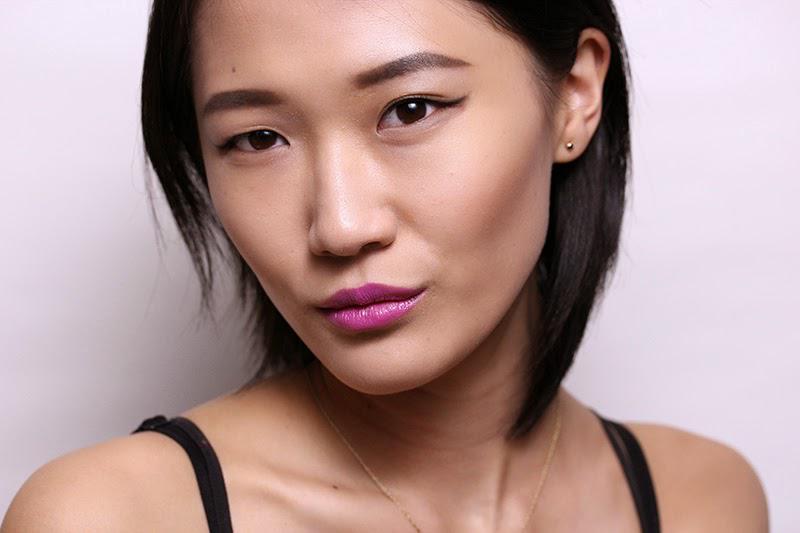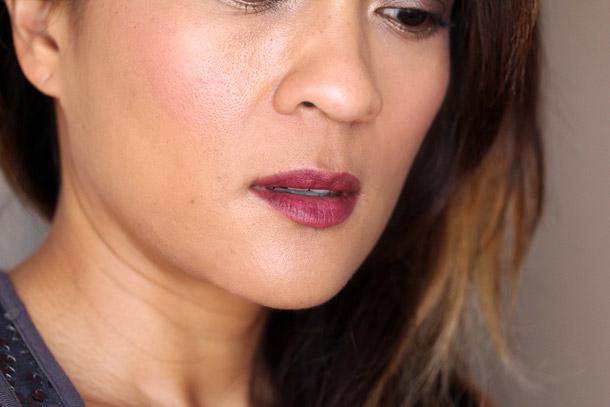The first image is the image on the left, the second image is the image on the right. Considering the images on both sides, is "An image shows an Asian model with lavender-tinted lips and thin black straps on her shoulders." valid? Answer yes or no. Yes. The first image is the image on the left, the second image is the image on the right. Analyze the images presented: Is the assertion "The woman in one of the images has her hand near her chin." valid? Answer yes or no. No. 